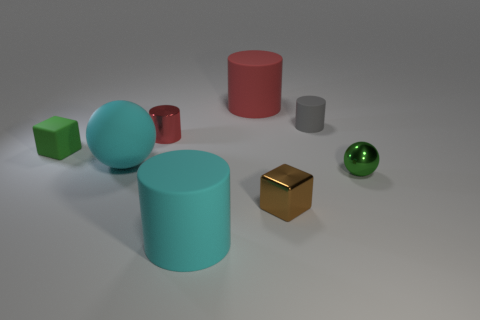There is a small object that is the same color as the matte block; what is it made of?
Offer a terse response. Metal. There is a big object that is behind the tiny rubber thing that is in front of the small gray object; what is it made of?
Keep it short and to the point. Rubber. What material is the green ball that is the same size as the brown metallic cube?
Keep it short and to the point. Metal. Are there any green blocks of the same size as the red metal cylinder?
Ensure brevity in your answer.  Yes. What color is the small object that is to the left of the big cyan matte sphere?
Make the answer very short. Green. Is there a brown thing that is on the right side of the large rubber cylinder that is behind the tiny rubber block?
Give a very brief answer. Yes. How many other objects are there of the same color as the matte block?
Give a very brief answer. 1. There is a thing that is on the left side of the cyan sphere; is it the same size as the green thing on the right side of the big red cylinder?
Give a very brief answer. Yes. There is a red object in front of the matte cylinder that is right of the metallic cube; what is its size?
Your answer should be very brief. Small. What material is the thing that is in front of the large cyan rubber ball and behind the brown cube?
Provide a short and direct response. Metal. 